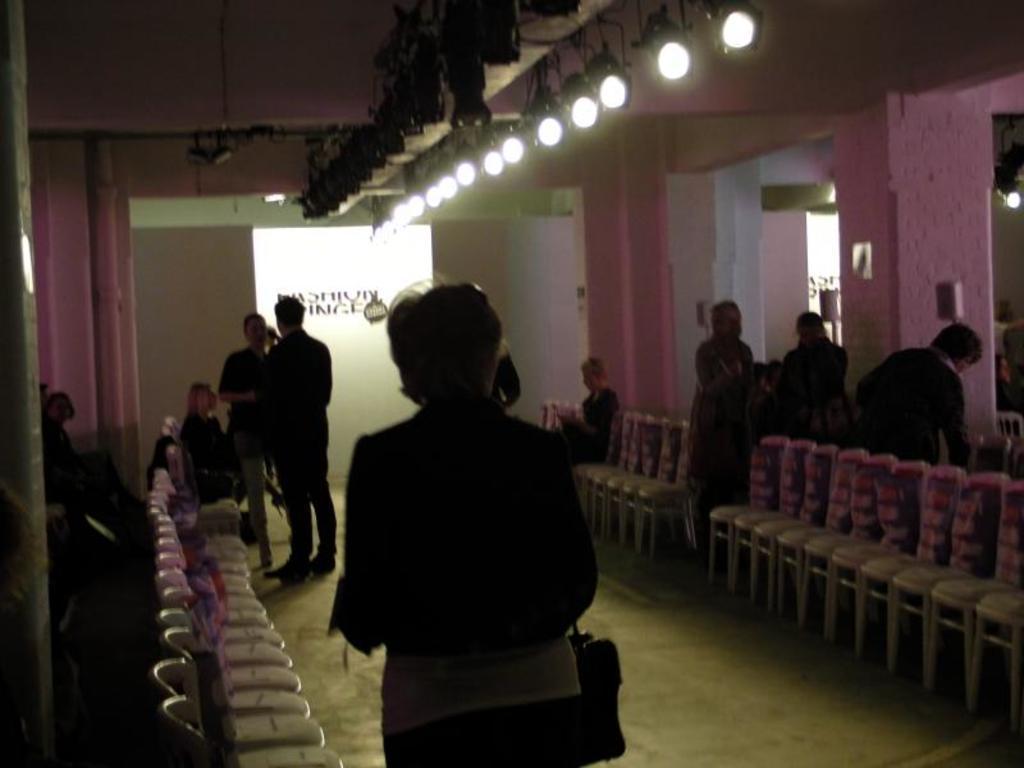Could you give a brief overview of what you see in this image? Here we can see a person is standing on the floor, and here a woman is siting and here a group of people are standing, and at above her are the lights. 